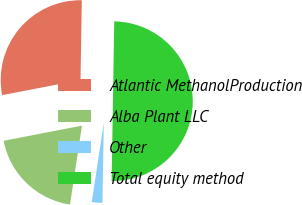Convert chart. <chart><loc_0><loc_0><loc_500><loc_500><pie_chart><fcel>Atlantic MethanolProduction<fcel>Alba Plant LLC<fcel>Other<fcel>Total equity method<nl><fcel>28.3%<fcel>19.56%<fcel>2.14%<fcel>50.0%<nl></chart> 